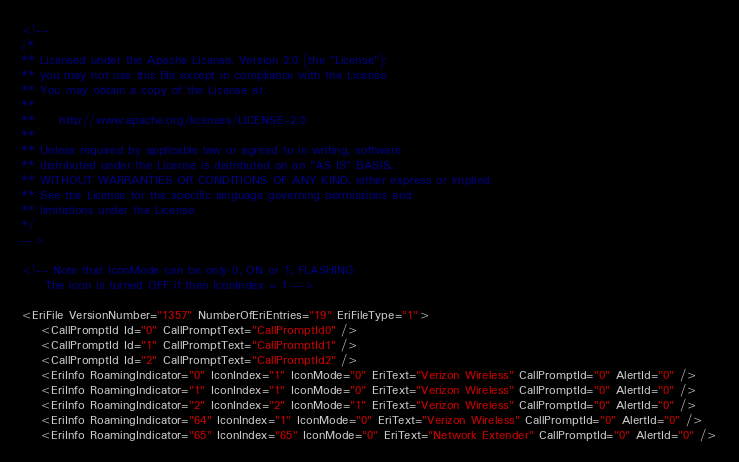Convert code to text. <code><loc_0><loc_0><loc_500><loc_500><_XML_><!--
/*
** Licensed under the Apache License, Version 2.0 (the "License");
** you may not use this file except in compliance with the License.
** You may obtain a copy of the License at
**
**     http://www.apache.org/licenses/LICENSE-2.0
**
** Unless required by applicable law or agreed to in writing, software
** distributed under the License is distributed on an "AS IS" BASIS,
** WITHOUT WARRANTIES OR CONDITIONS OF ANY KIND, either express or implied.
** See the License for the specific language governing permissions and
** limitations under the License.
*/
-->

<!-- Note that IconMode can be only 0, ON or 1, FLASHING
     The icon is turned OFF if then IconIndex = 1 -->

<EriFile VersionNumber="1357" NumberOfEriEntries="19" EriFileType="1">
    <CallPromptId Id="0" CallPromptText="CallPromptId0" />
    <CallPromptId Id="1" CallPromptText="CallPromptId1" />
    <CallPromptId Id="2" CallPromptText="CallPromptId2" />
    <EriInfo RoamingIndicator="0" IconIndex="1" IconMode="0" EriText="Verizon Wireless" CallPromptId="0" AlertId="0" />
    <EriInfo RoamingIndicator="1" IconIndex="1" IconMode="0" EriText="Verizon Wireless" CallPromptId="0" AlertId="0" />
    <EriInfo RoamingIndicator="2" IconIndex="2" IconMode="1" EriText="Verizon Wireless" CallPromptId="0" AlertId="0" />
    <EriInfo RoamingIndicator="64" IconIndex="1" IconMode="0" EriText="Verizon Wireless" CallPromptId="0" AlertId="0" />
    <EriInfo RoamingIndicator="65" IconIndex="65" IconMode="0" EriText="Network Extender" CallPromptId="0" AlertId="0" /></code> 